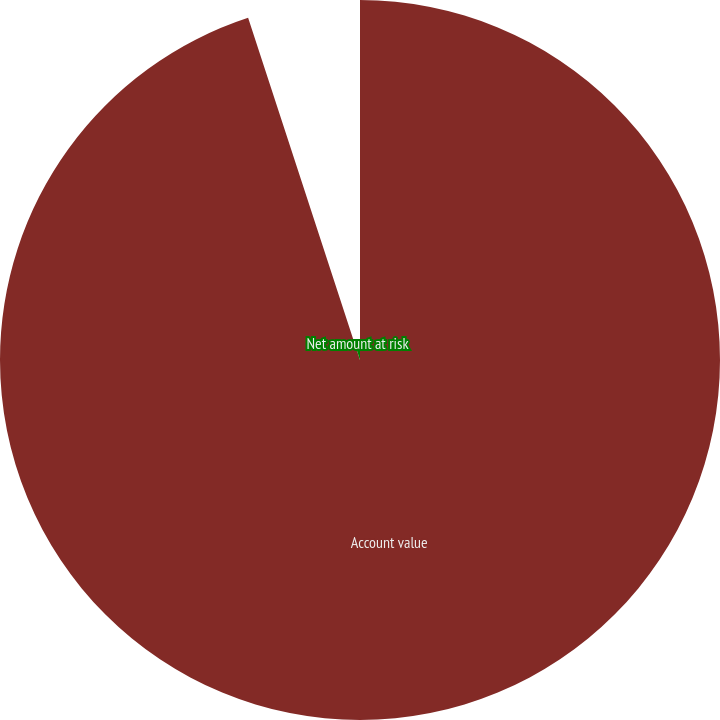Convert chart to OTSL. <chart><loc_0><loc_0><loc_500><loc_500><pie_chart><fcel>Account value<fcel>Net amount at risk<nl><fcel>94.97%<fcel>5.03%<nl></chart> 